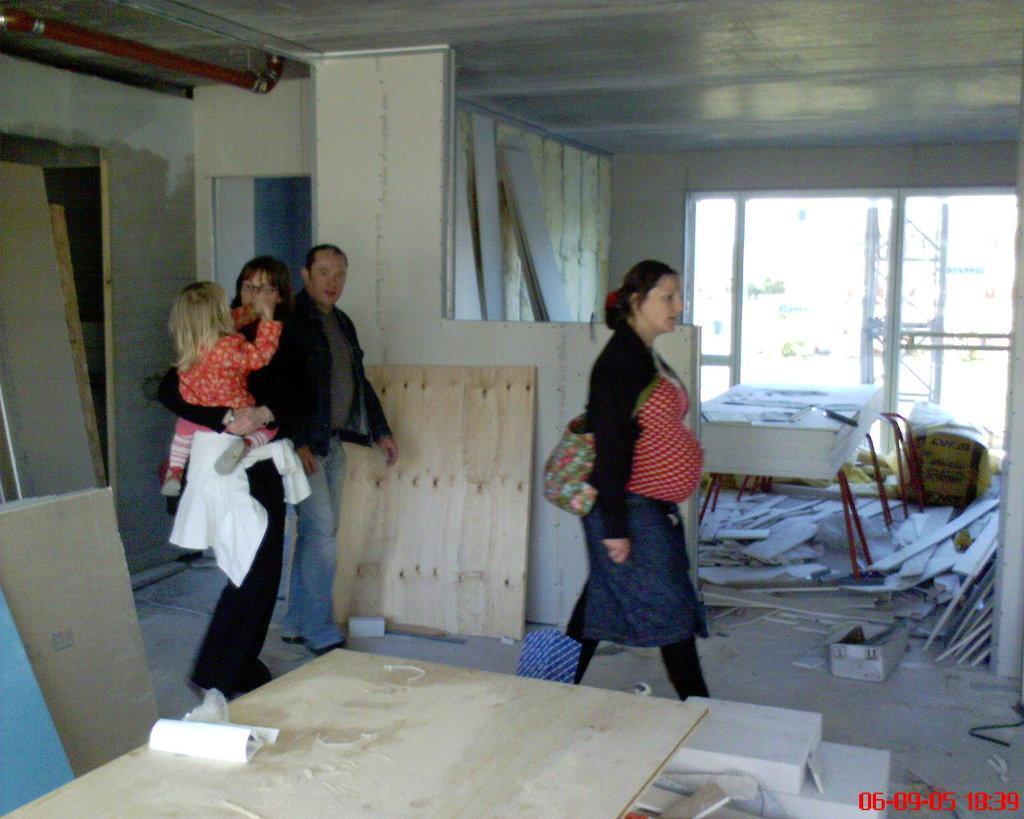Could you give a brief overview of what you see in this image? There are three people walking. This woman is holding a girl. I can see the wooden boards. This is the wall. I can see a window. This looks like a table with few objects on it. I think this is a pipe, which is red in color is attached to the roof. 